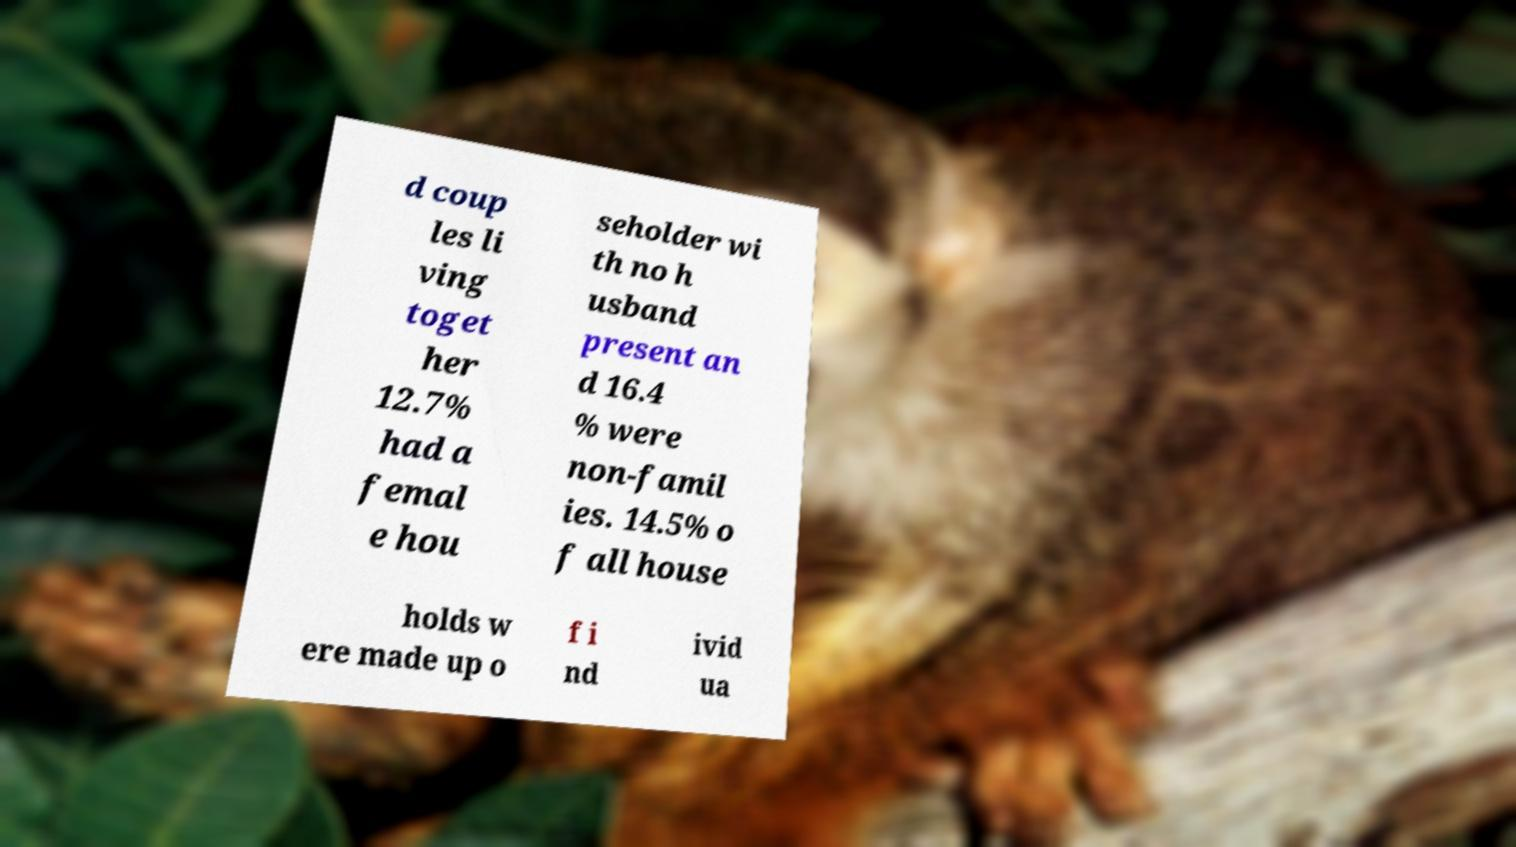Please identify and transcribe the text found in this image. d coup les li ving toget her 12.7% had a femal e hou seholder wi th no h usband present an d 16.4 % were non-famil ies. 14.5% o f all house holds w ere made up o f i nd ivid ua 